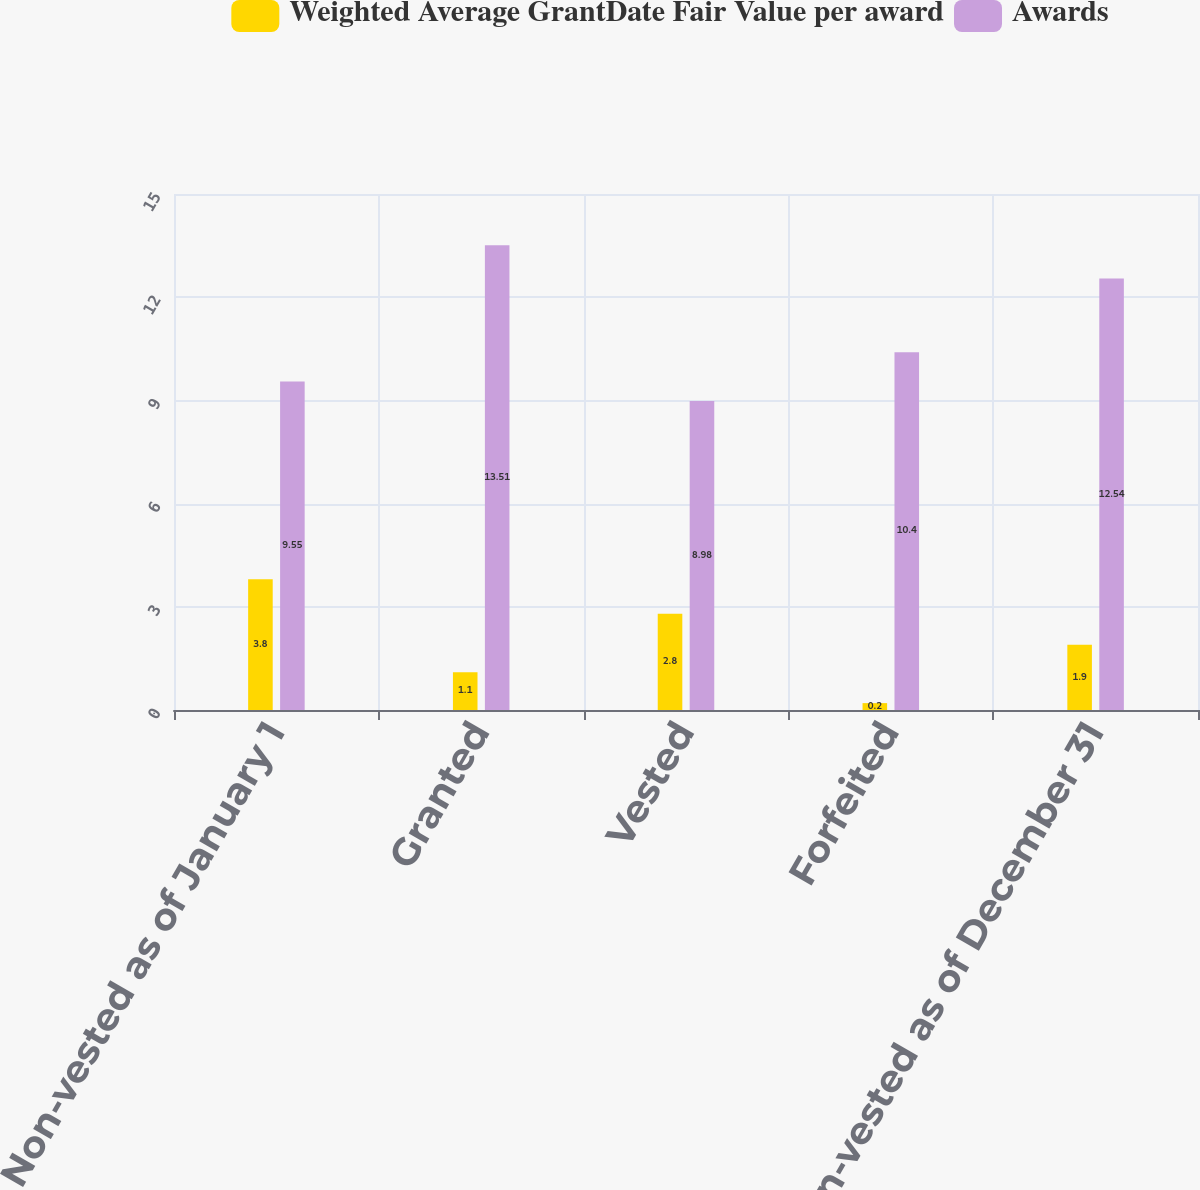<chart> <loc_0><loc_0><loc_500><loc_500><stacked_bar_chart><ecel><fcel>Non-vested as of January 1<fcel>Granted<fcel>Vested<fcel>Forfeited<fcel>Non-vested as of December 31<nl><fcel>Weighted Average GrantDate Fair Value per award<fcel>3.8<fcel>1.1<fcel>2.8<fcel>0.2<fcel>1.9<nl><fcel>Awards<fcel>9.55<fcel>13.51<fcel>8.98<fcel>10.4<fcel>12.54<nl></chart> 